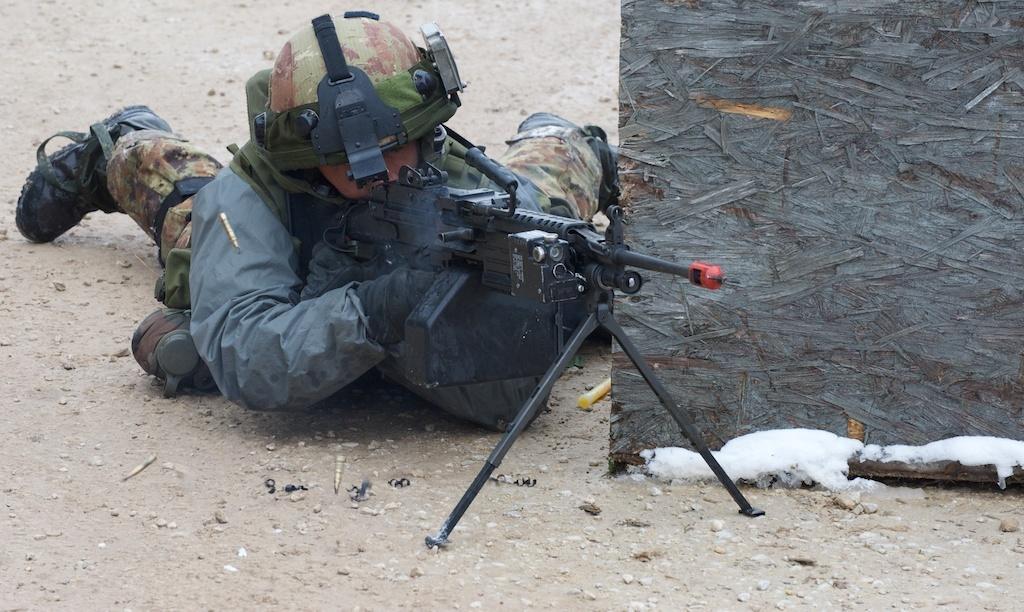Describe this image in one or two sentences. In this image I can see a person laying and the person is wearing military dress and holding a gun. The gun is in black color. 